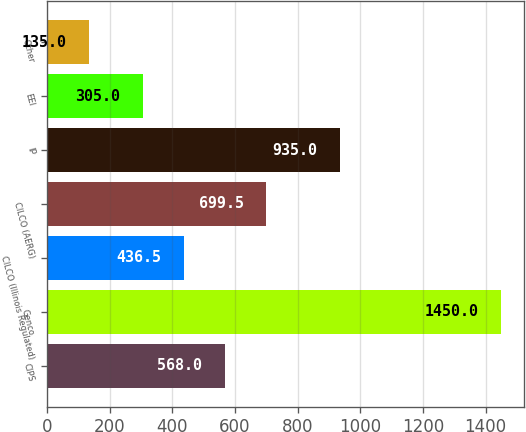Convert chart. <chart><loc_0><loc_0><loc_500><loc_500><bar_chart><fcel>CIPS<fcel>Genco<fcel>CILCO (Illinois Regulated)<fcel>CILCO (AERG)<fcel>IP<fcel>EEI<fcel>Other<nl><fcel>568<fcel>1450<fcel>436.5<fcel>699.5<fcel>935<fcel>305<fcel>135<nl></chart> 